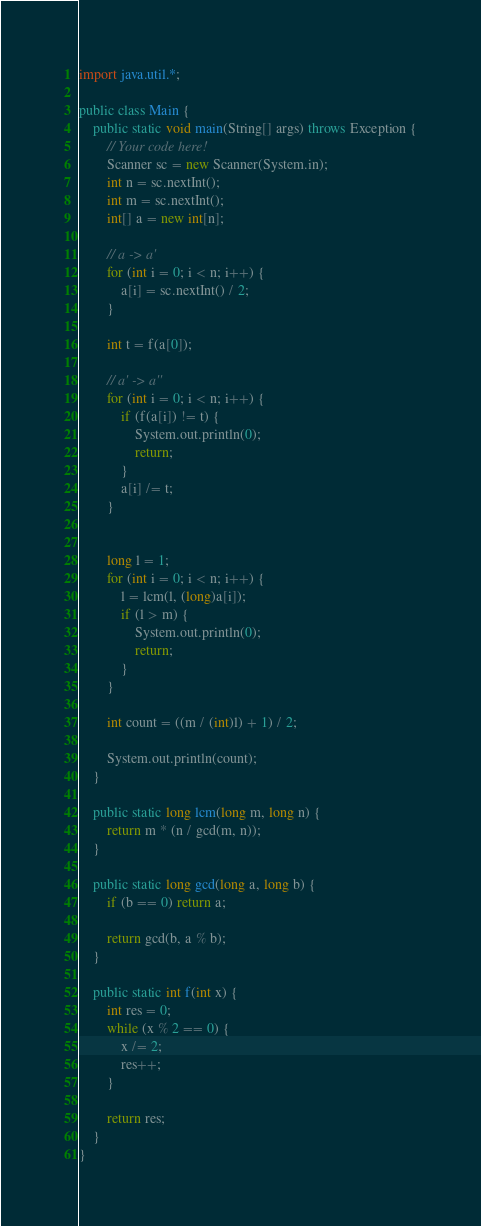<code> <loc_0><loc_0><loc_500><loc_500><_Java_>import java.util.*;

public class Main {
    public static void main(String[] args) throws Exception {
        // Your code here!
        Scanner sc = new Scanner(System.in);
        int n = sc.nextInt();
        int m = sc.nextInt();
        int[] a = new int[n];
        
        // a -> a'
        for (int i = 0; i < n; i++) {
            a[i] = sc.nextInt() / 2;
        }
        
        int t = f(a[0]);
        
        // a' -> a''
        for (int i = 0; i < n; i++) {
            if (f(a[i]) != t) {
                System.out.println(0);
                return;
            }
            a[i] /= t;
        }
        
        
        long l = 1;
        for (int i = 0; i < n; i++) {
            l = lcm(l, (long)a[i]);
            if (l > m) {
                System.out.println(0);
                return;
            }
        }
        
        int count = ((m / (int)l) + 1) / 2;
        
        System.out.println(count);
    }
    
    public static long lcm(long m, long n) {
        return m * (n / gcd(m, n));
    }
    
    public static long gcd(long a, long b) {
        if (b == 0) return a;
        
        return gcd(b, a % b);
    }
    
    public static int f(int x) {
        int res = 0;
        while (x % 2 == 0) {
            x /= 2;
            res++;
        }
        
        return res;
    }
}
</code> 